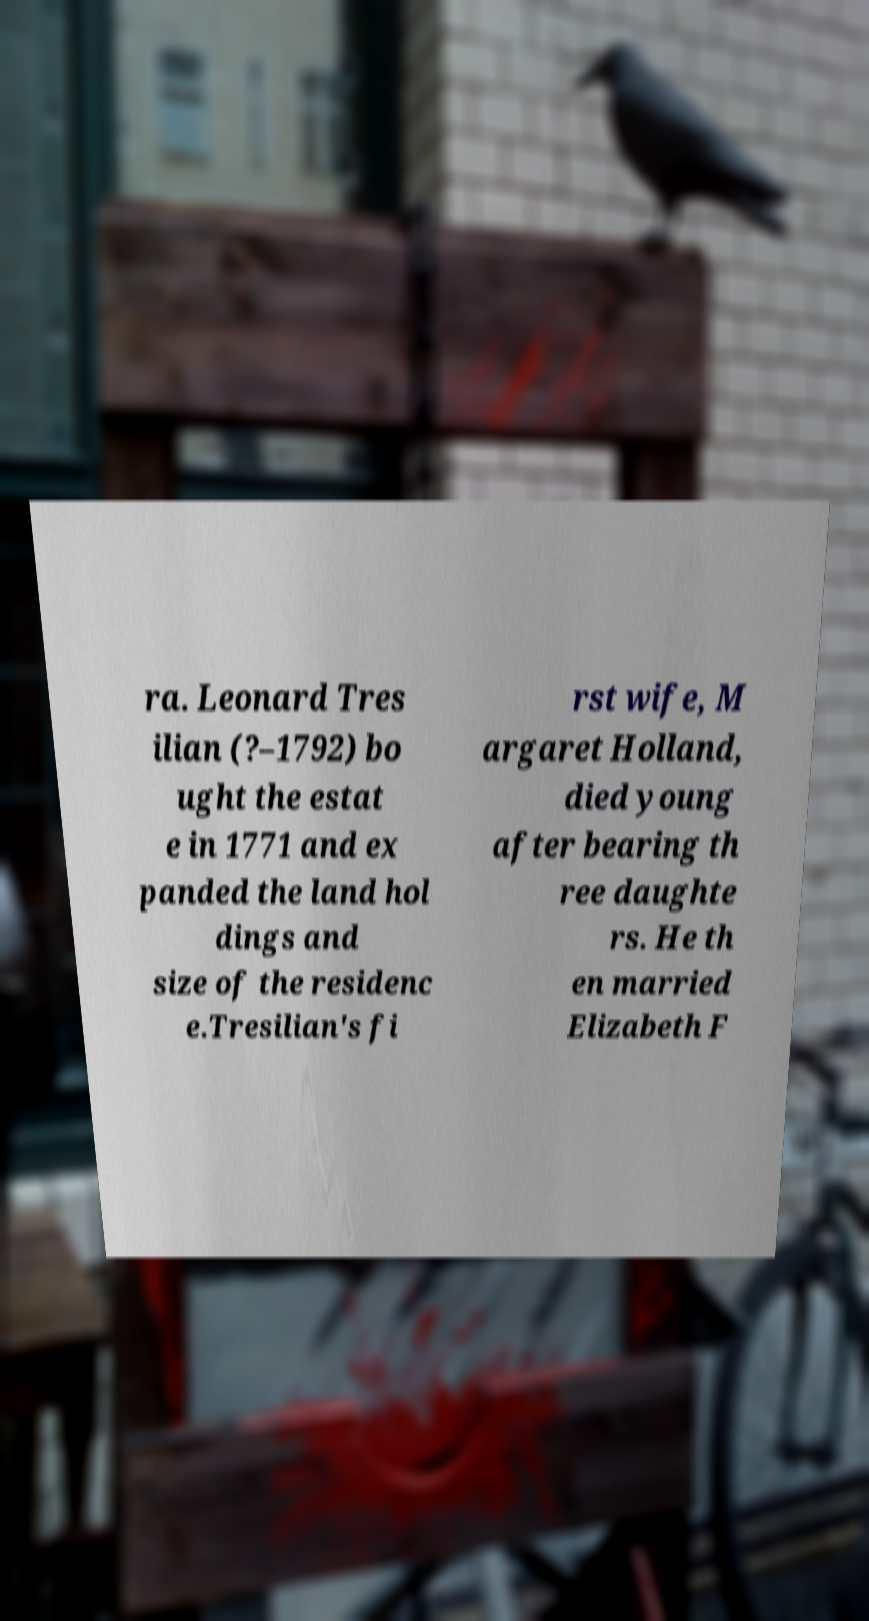Please identify and transcribe the text found in this image. ra. Leonard Tres ilian (?–1792) bo ught the estat e in 1771 and ex panded the land hol dings and size of the residenc e.Tresilian's fi rst wife, M argaret Holland, died young after bearing th ree daughte rs. He th en married Elizabeth F 